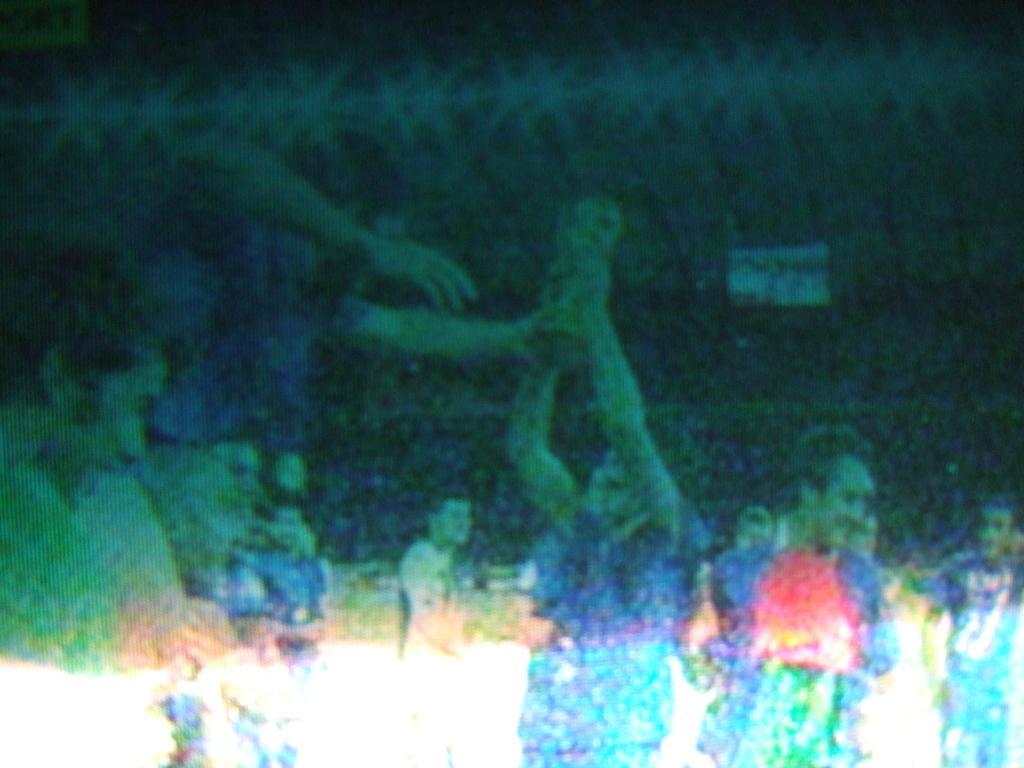Please provide a concise description of this image. In the picture I can see people. The picture is not clear. 